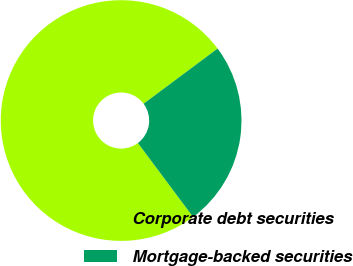<chart> <loc_0><loc_0><loc_500><loc_500><pie_chart><fcel>Corporate debt securities<fcel>Mortgage-backed securities<nl><fcel>75.0%<fcel>25.0%<nl></chart> 